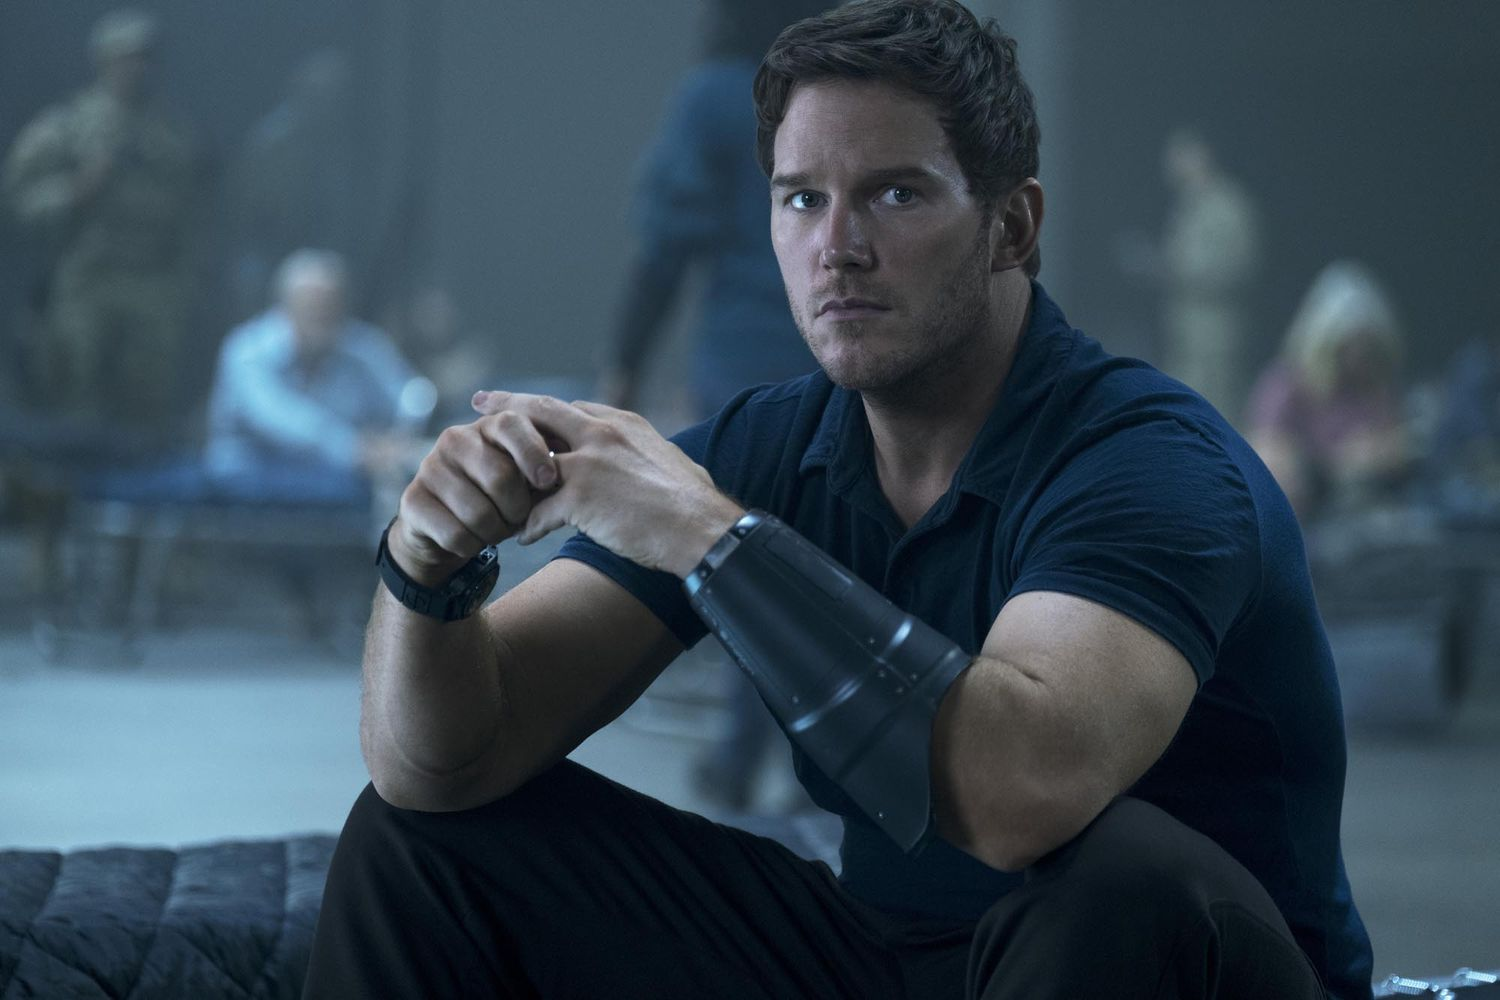What do you think is happening in this scene? It appears to be a tense moment, possibly during an emergency or mission. The character is focused, perhaps planning his next move or awaiting critical information. The presence of soldiers and other people in the background suggests a military or crisis situation. What might the device he is holding be? The black device he is holding could be anything from a communication tool to a piece of technical equipment essential for the mission. Its precise purpose is unclear, but it certainly seems to play an important role in the unfolding events. Can you describe the background and its significance? The background is blurred, but it reveals several individuals, some of whom appear to be soldiers. This suggests the setting is bustling and filled with people on high alert. The blurred figures convey a sense of movement and urgency, highlighting the gravity of the situation the central character is involved in. 